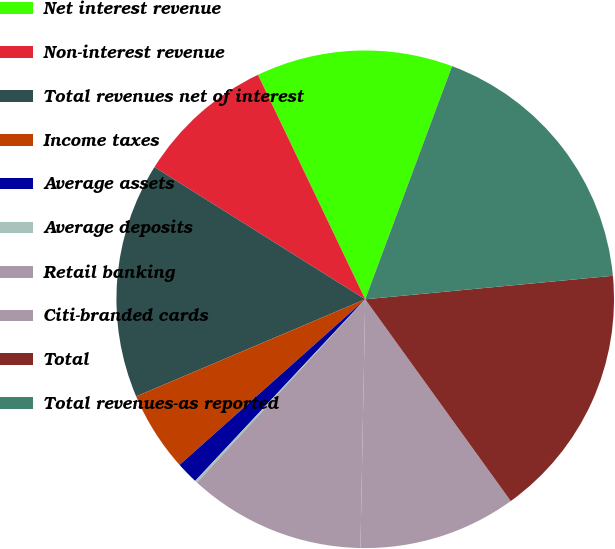Convert chart. <chart><loc_0><loc_0><loc_500><loc_500><pie_chart><fcel>Net interest revenue<fcel>Non-interest revenue<fcel>Total revenues net of interest<fcel>Income taxes<fcel>Average assets<fcel>Average deposits<fcel>Retail banking<fcel>Citi-branded cards<fcel>Total<fcel>Total revenues-as reported<nl><fcel>12.77%<fcel>8.99%<fcel>15.3%<fcel>5.21%<fcel>1.43%<fcel>0.16%<fcel>11.51%<fcel>10.25%<fcel>16.56%<fcel>17.82%<nl></chart> 